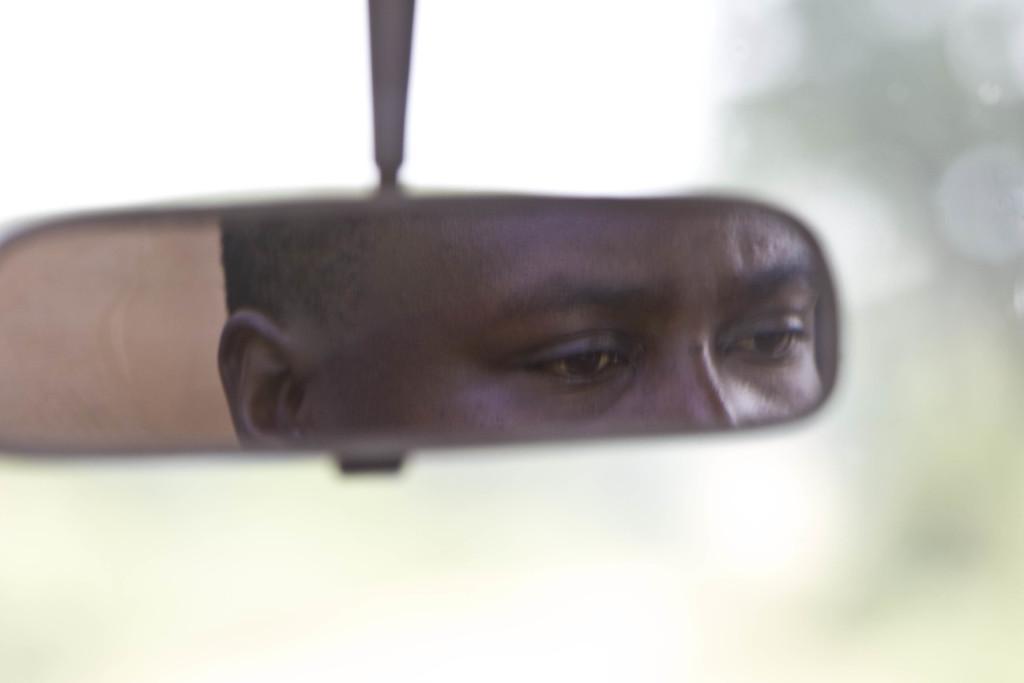Describe this image in one or two sentences. In this image there is a reflection of a person on the mirror , and there is blur background. 